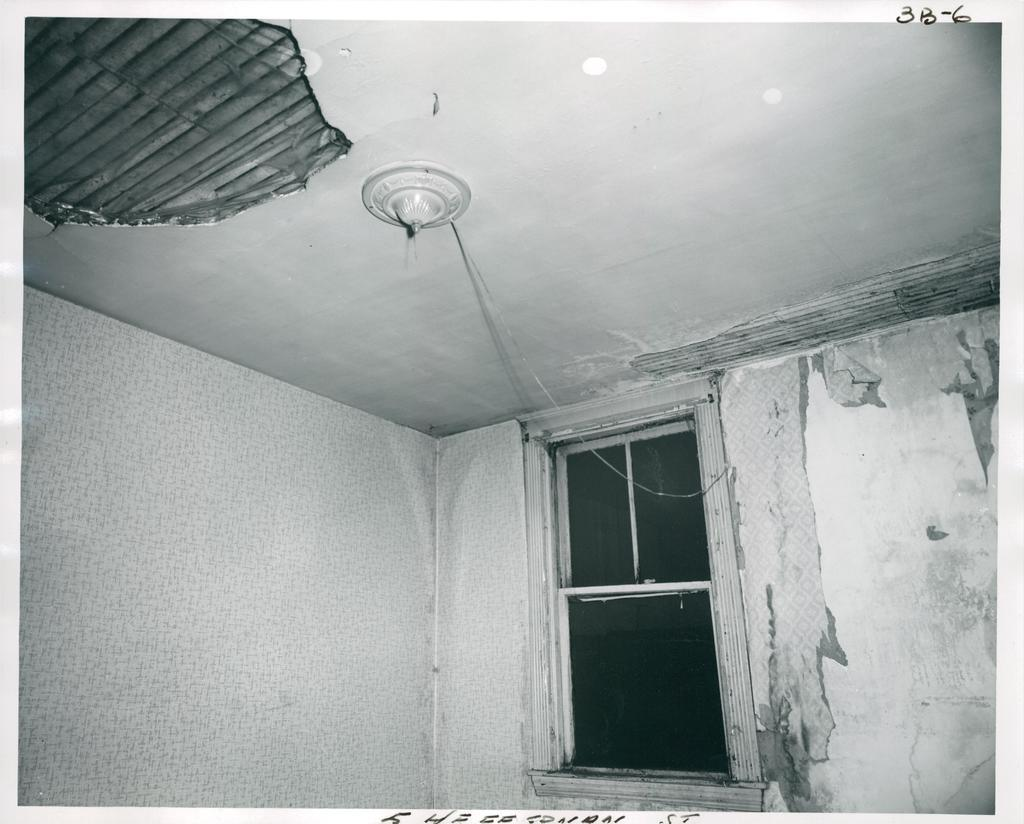What type of structure can be seen in the image? There is a wall, window, and roof visible in the image. Can you describe the window in the image? There is a window in the image, but its specific characteristics are not mentioned in the facts. What is on top of the roof in the image? There is light on the roof in the image. What else can be seen in the image besides the wall, window, and roof? There is a wire and text at the bottom of the image. What type of rat can be seen in the jar on the roof in the image? There is no rat or jar present in the image. How does the comb help with the light on the roof in the image? There is no comb present in the image, and therefore it cannot help with the light on the roof. 